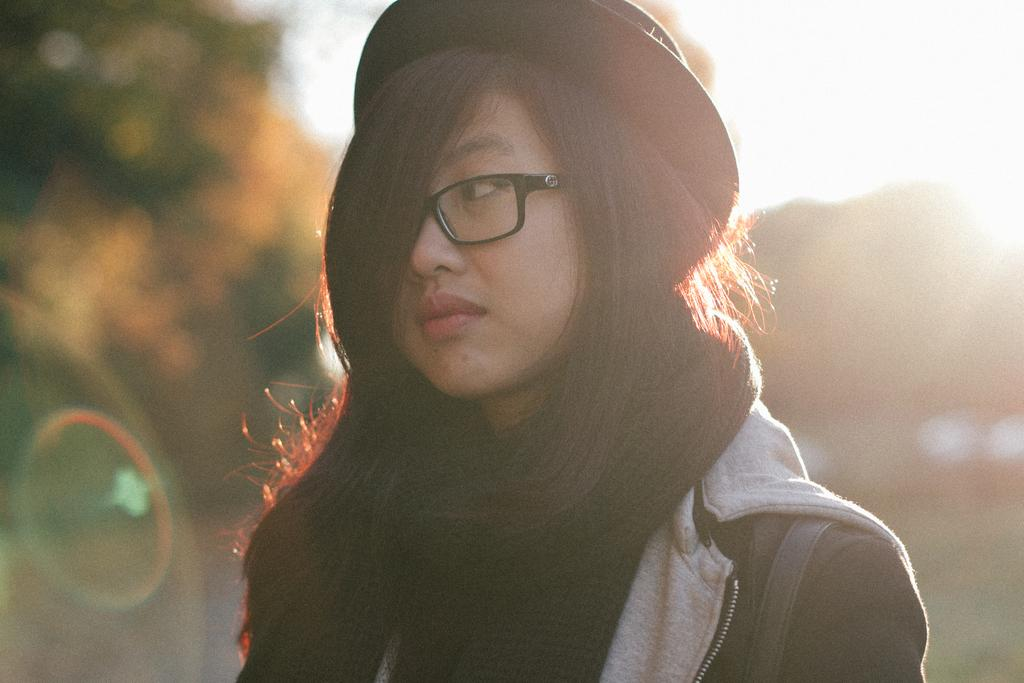Where was the image taken? The image was taken outside. What can be seen in the foreground of the image? There is a person in the foreground of the image. What accessories is the person wearing? The person is wearing a hat and spectacles. What is visible in the background of the image? There is sky and trees visible in the background of the image. What type of line is visible in the image? There is no line visible in the image. What caption would you give to the image? It is not possible to provide a caption for the image based solely on the provided facts. 